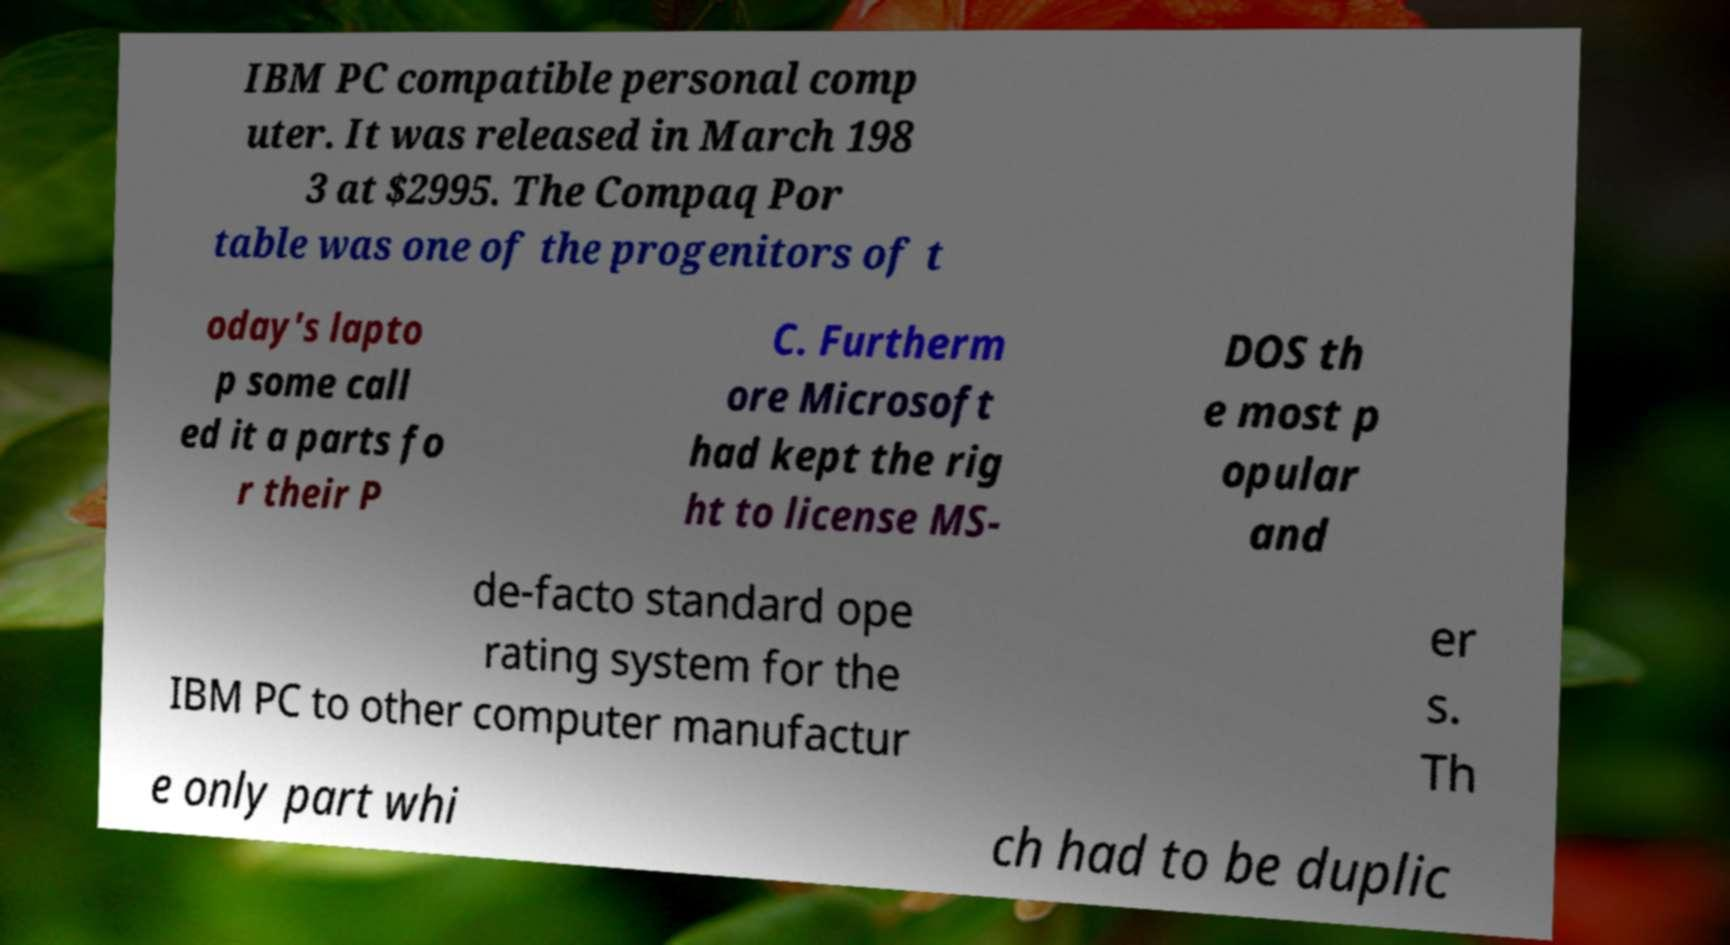Can you accurately transcribe the text from the provided image for me? IBM PC compatible personal comp uter. It was released in March 198 3 at $2995. The Compaq Por table was one of the progenitors of t oday's lapto p some call ed it a parts fo r their P C. Furtherm ore Microsoft had kept the rig ht to license MS- DOS th e most p opular and de-facto standard ope rating system for the IBM PC to other computer manufactur er s. Th e only part whi ch had to be duplic 